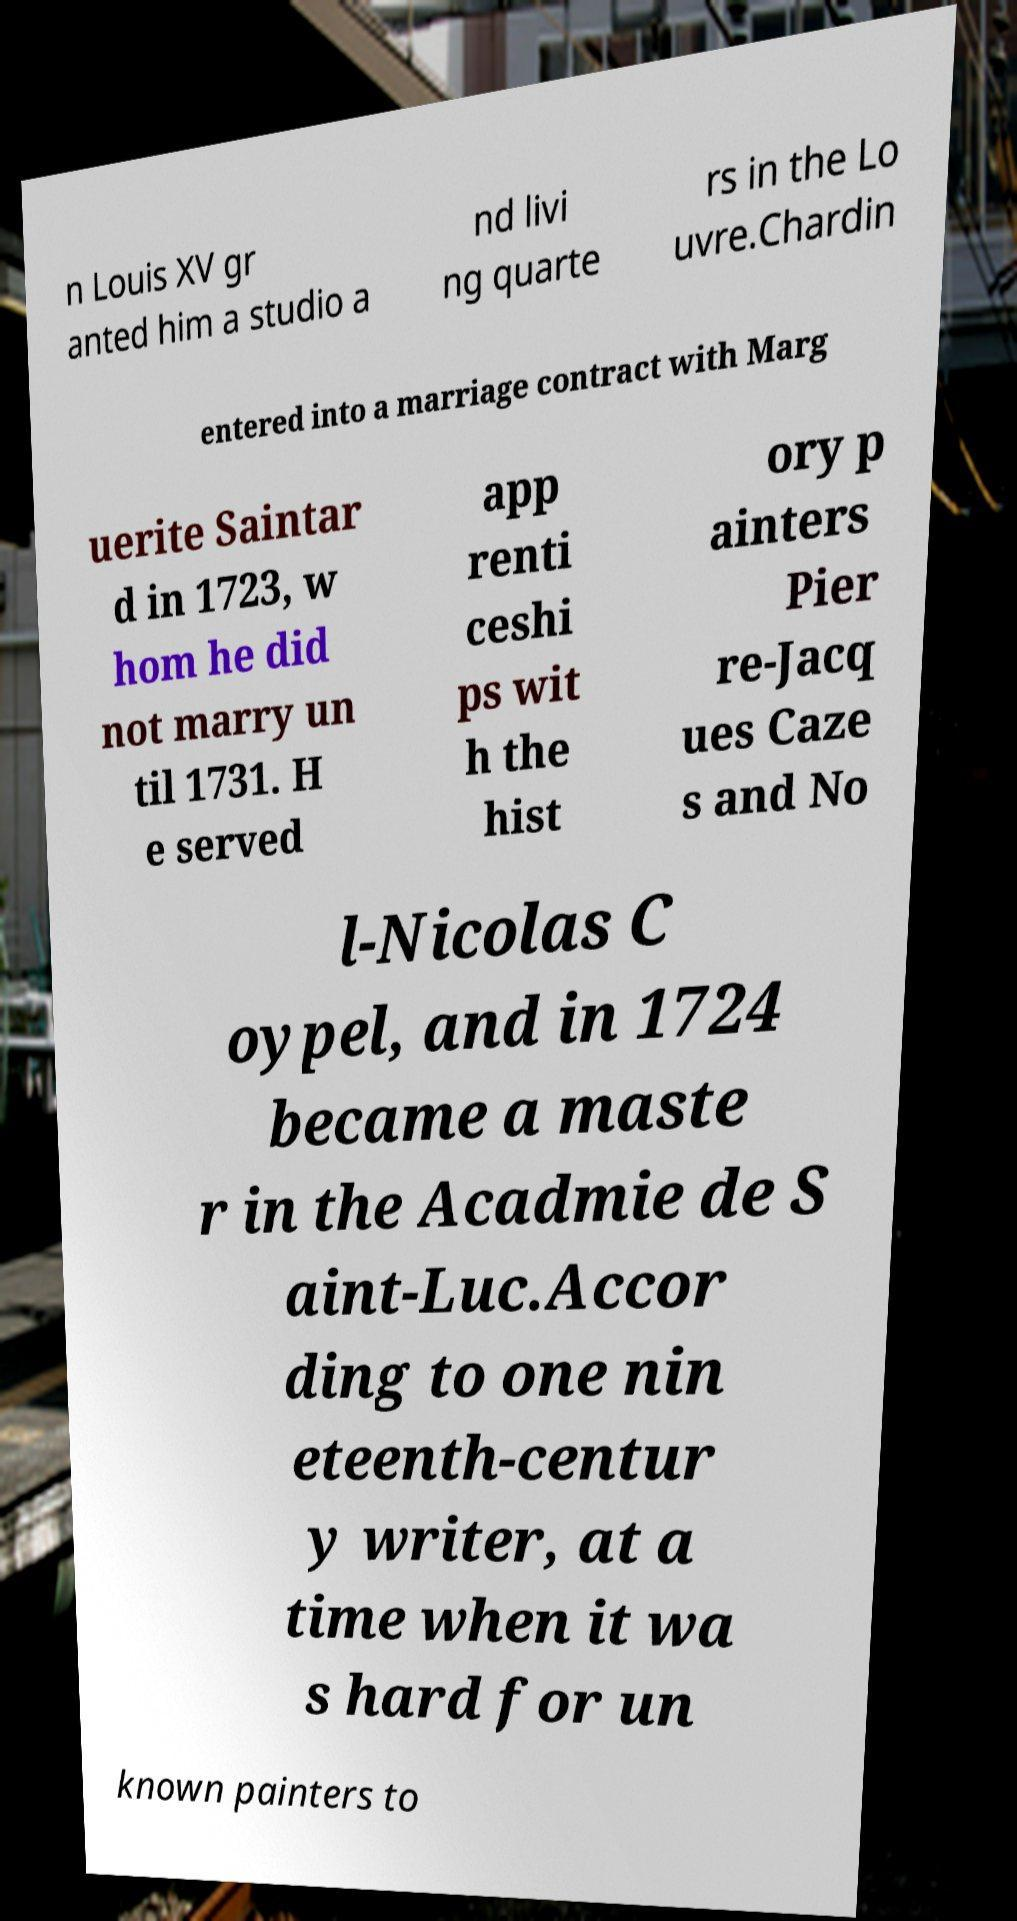I need the written content from this picture converted into text. Can you do that? n Louis XV gr anted him a studio a nd livi ng quarte rs in the Lo uvre.Chardin entered into a marriage contract with Marg uerite Saintar d in 1723, w hom he did not marry un til 1731. H e served app renti ceshi ps wit h the hist ory p ainters Pier re-Jacq ues Caze s and No l-Nicolas C oypel, and in 1724 became a maste r in the Acadmie de S aint-Luc.Accor ding to one nin eteenth-centur y writer, at a time when it wa s hard for un known painters to 